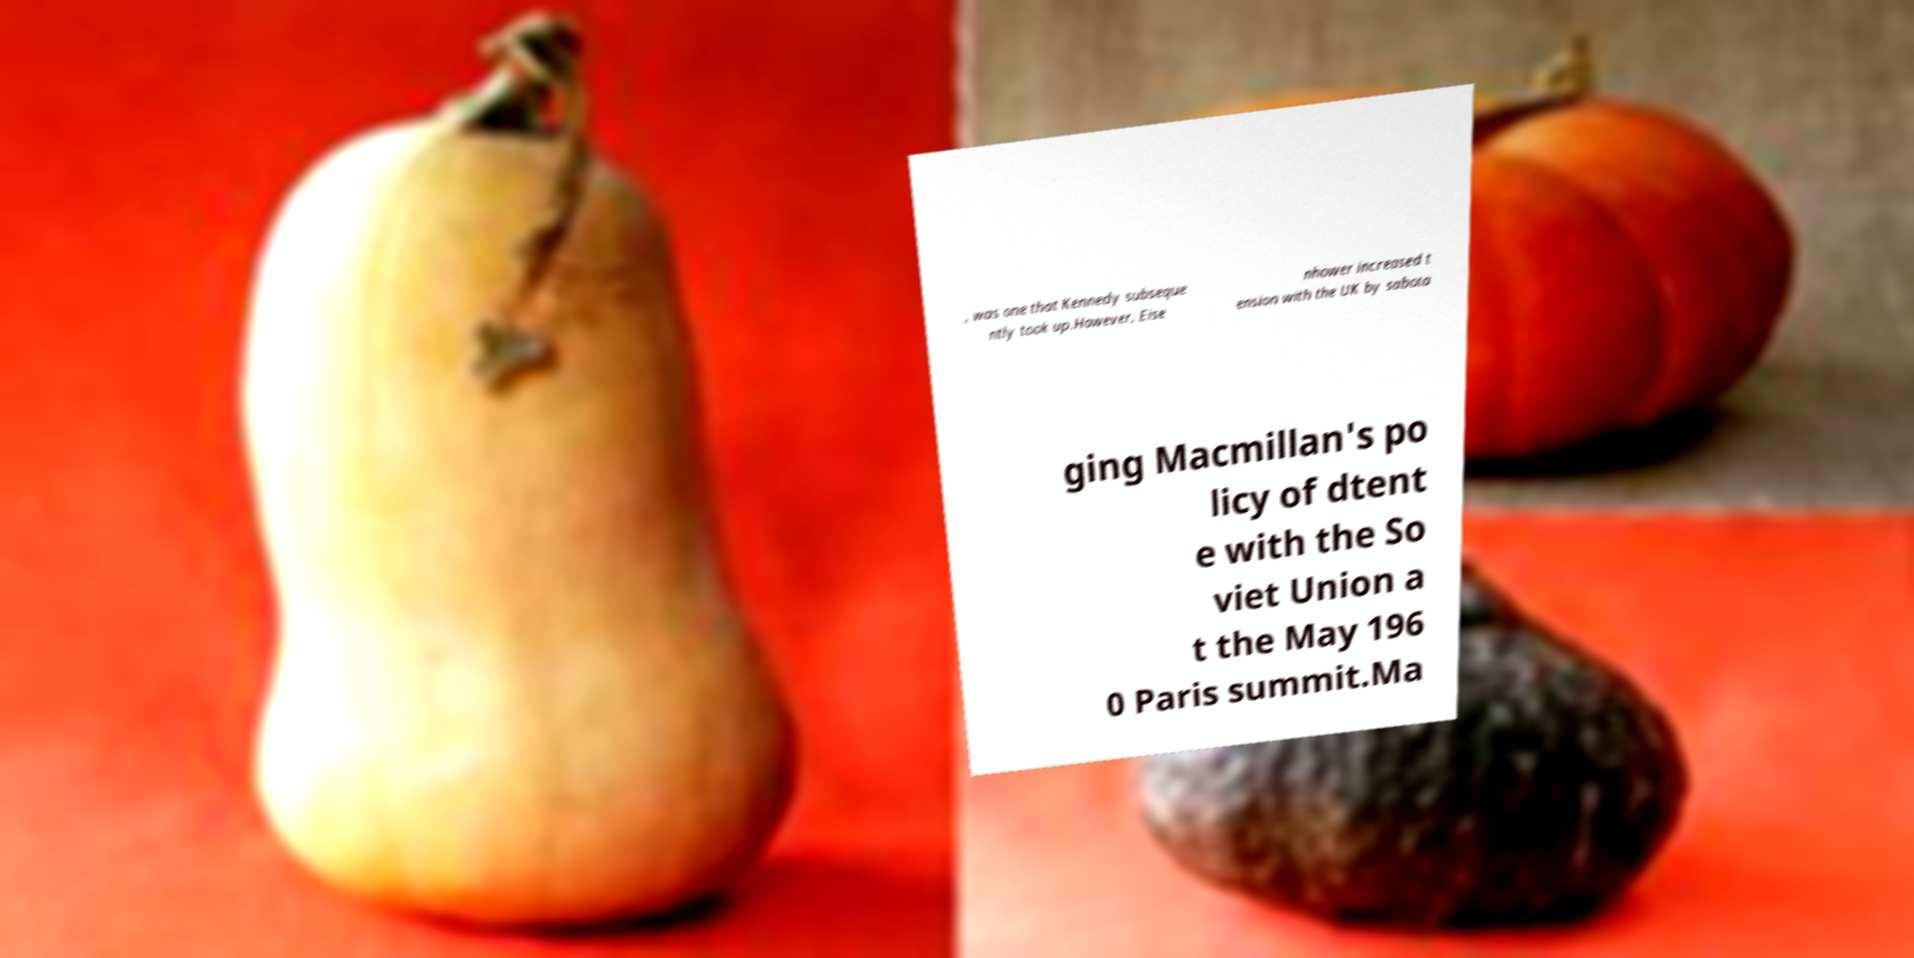Could you extract and type out the text from this image? , was one that Kennedy subseque ntly took up.However, Eise nhower increased t ension with the UK by sabota ging Macmillan's po licy of dtent e with the So viet Union a t the May 196 0 Paris summit.Ma 